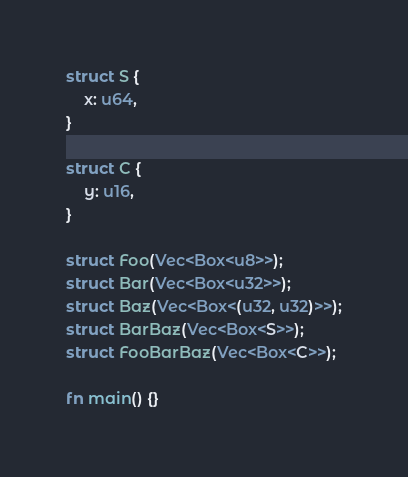<code> <loc_0><loc_0><loc_500><loc_500><_Rust_>struct S {
    x: u64,
}

struct C {
    y: u16,
}

struct Foo(Vec<Box<u8>>);
struct Bar(Vec<Box<u32>>);
struct Baz(Vec<Box<(u32, u32)>>);
struct BarBaz(Vec<Box<S>>);
struct FooBarBaz(Vec<Box<C>>);

fn main() {}
</code> 